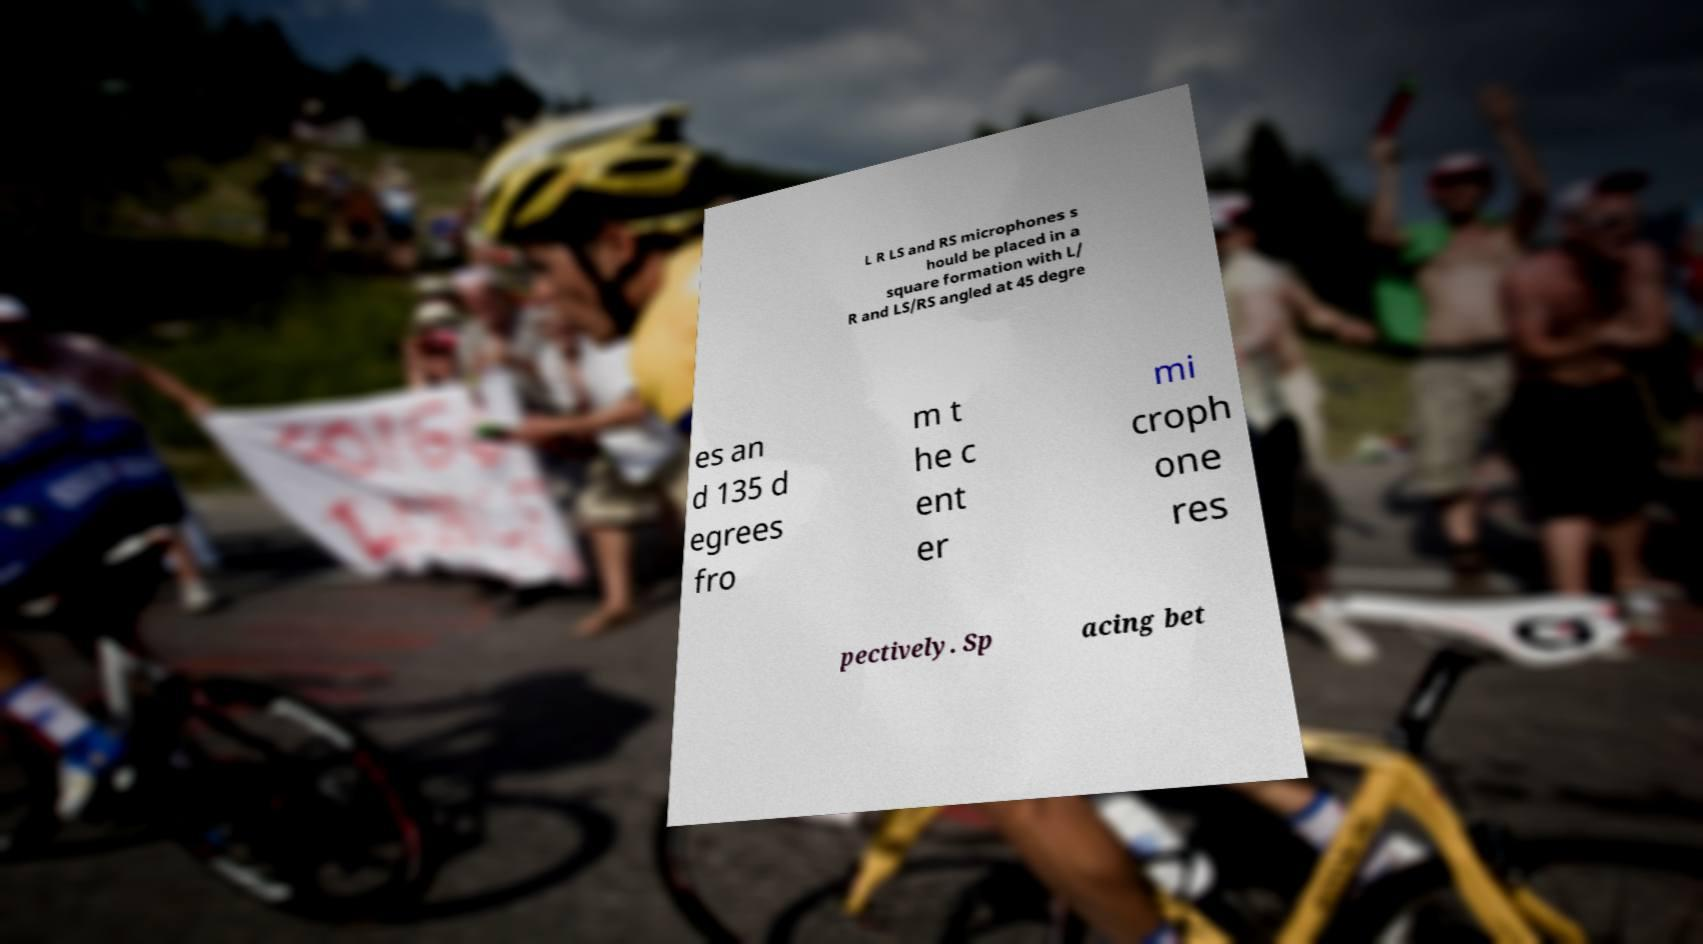Could you assist in decoding the text presented in this image and type it out clearly? L R LS and RS microphones s hould be placed in a square formation with L/ R and LS/RS angled at 45 degre es an d 135 d egrees fro m t he c ent er mi croph one res pectively. Sp acing bet 